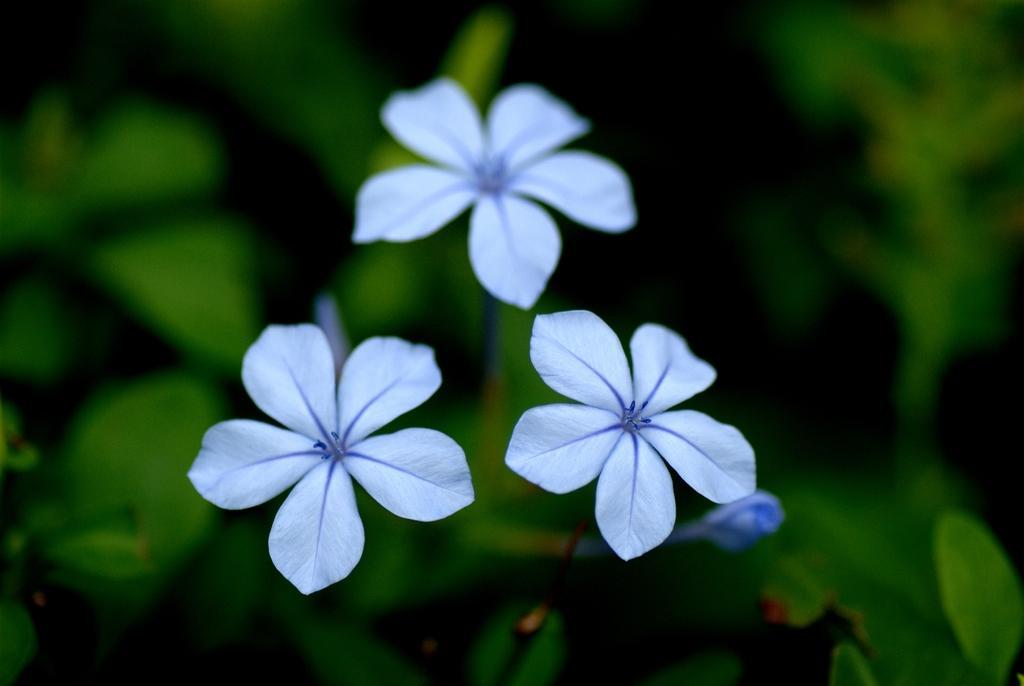How would you summarize this image in a sentence or two? In this image there are plants with the flowers on it. 